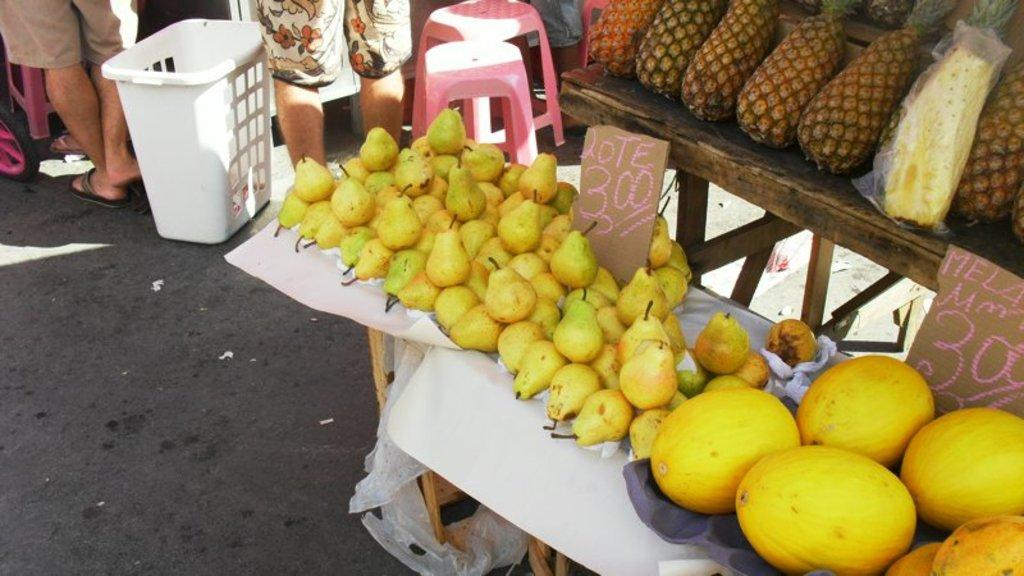What is displayed on the rack in the image? There are many fruits on the rack in the image. What type of furniture is present in the image? There are stools in the image. Can you describe the people in the image? There are people in the image. How are the prices displayed in the image? There are two price boards in the image. What type of deer can be seen wearing a boot in the image? There is no deer or boot present in the image. 